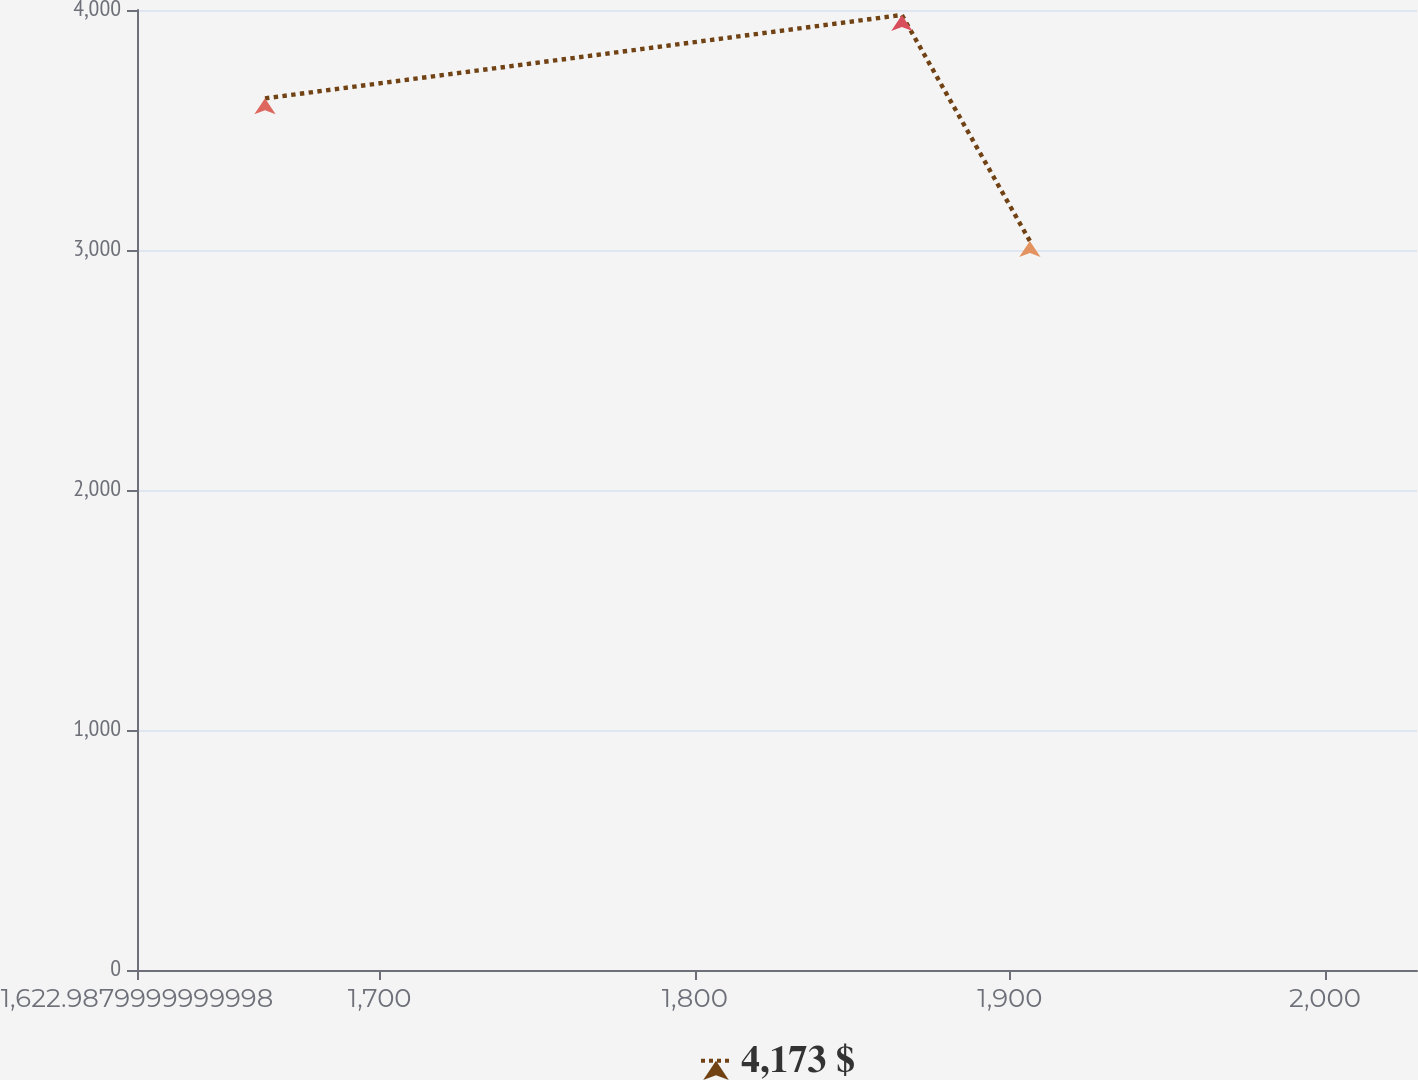Convert chart to OTSL. <chart><loc_0><loc_0><loc_500><loc_500><line_chart><ecel><fcel>4,173 $<nl><fcel>1663.61<fcel>3631.86<nl><fcel>1865.73<fcel>3979.22<nl><fcel>1906.35<fcel>3037.52<nl><fcel>2069.83<fcel>680.03<nl></chart> 